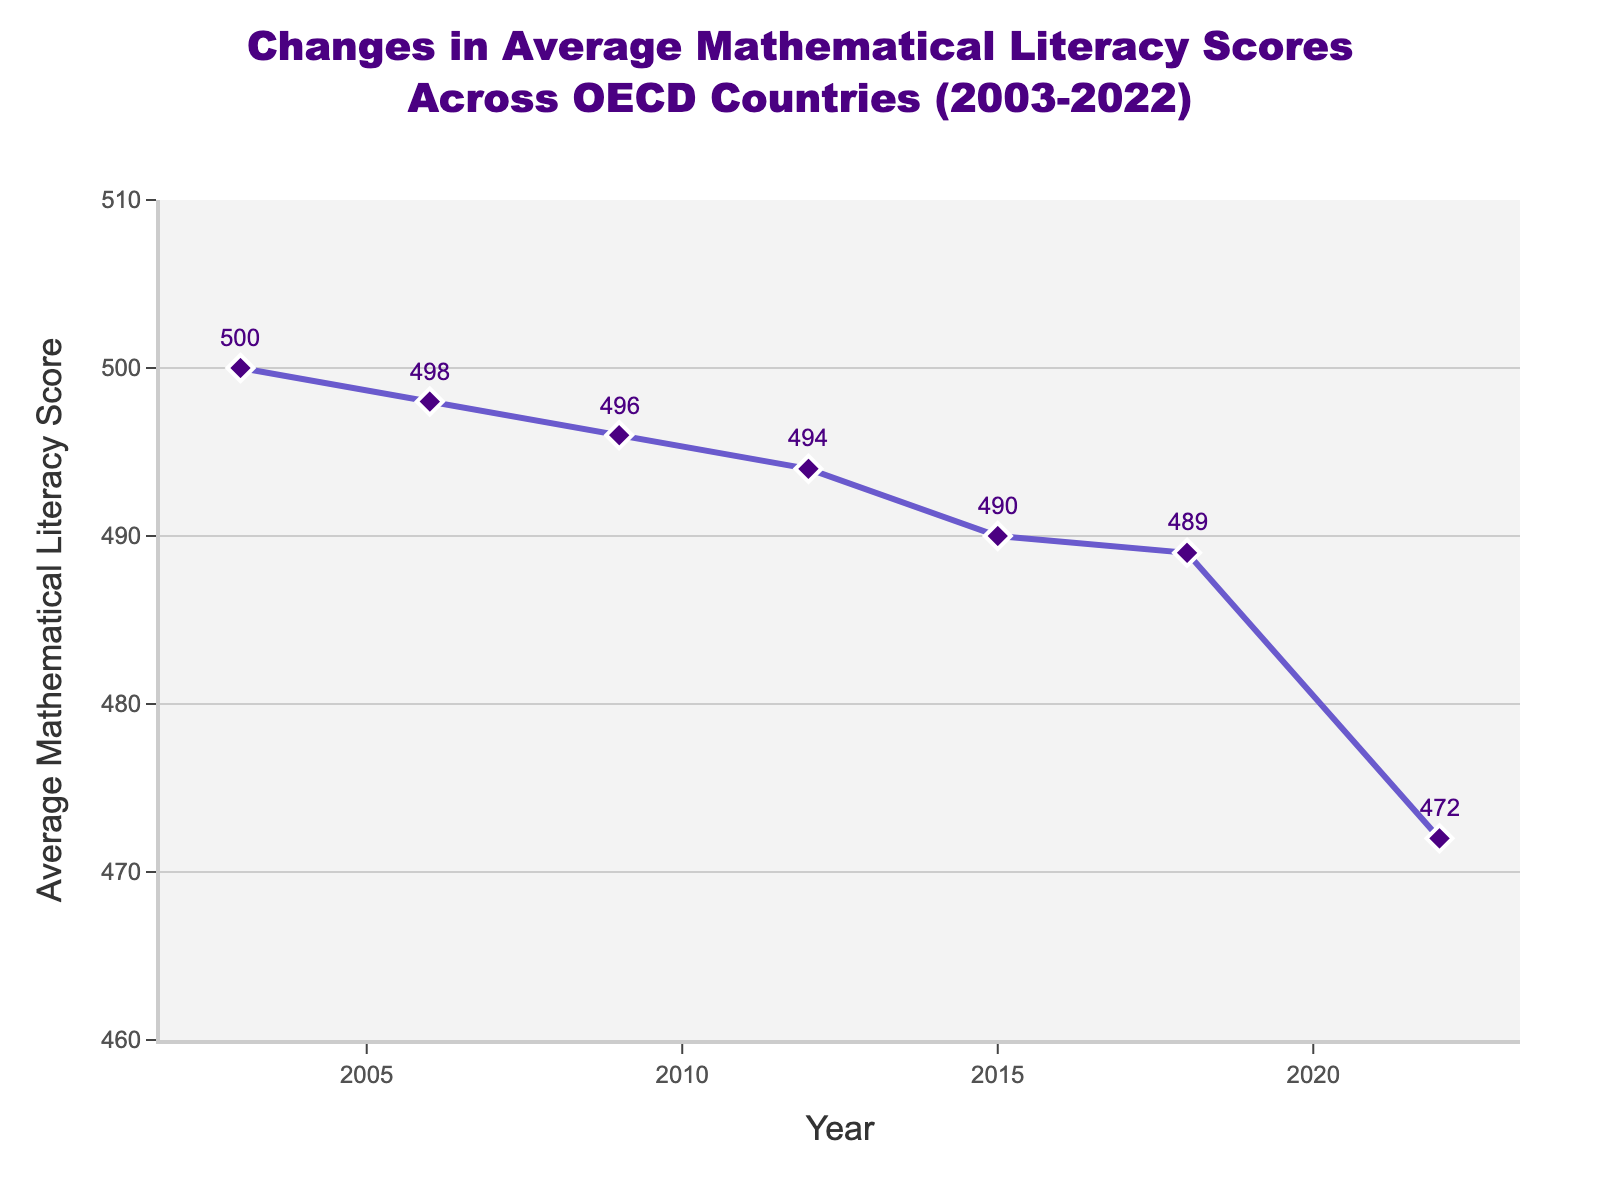What's the average mathematical literacy score from 2003 to 2022? To calculate the average score, sum all the scores and divide by the number of years. The scores are 500, 498, 496, 494, 490, 489, and 472. The sum is 3439, and there are 7 years. The average is 3439 / 7.
Answer: 491.29 In which year did the average mathematical literacy score see the biggest drop compared to the previous measurement? Looking at the differences between consecutive years: 500 to 498 (2), 498 to 496 (2), 496 to 494 (2), 494 to 490 (4), 490 to 489 (1), and 489 to 472 (17). The biggest drop is between 2018 and 2022.
Answer: 2022 How much did the average mathematical literacy score decrease from 2003 to 2022? Subtract the 2022 score from the 2003 score: 500 - 472.
Answer: 28 Which year had the highest average mathematical literacy score, and what was the value? The year with the highest score is easily identified by looking at the highest point on the line, which is 2003 with a score of 500.
Answer: 2003, 500 Is the average mathematical literacy score in 2015 higher than in 2012? Compare the two scores: 494 in 2012 and 490 in 2015. 490 is less than 494.
Answer: No By how much did the average mathematical literacy score change from 2009 to 2012? Subtract the 2012 score from the 2009 score: 496 - 494.
Answer: 2 What pattern can you observe in the average mathematical literacy scores from 2003 to 2022? The scores generally decrease over time, with slight fluctuations. The overall trend shows a downward slope.
Answer: Decreasing trend Which year had the smallest decrease in average mathematical literacy score compared to the previous measurement? Compare the differences: 500 to 498 (2), 498 to 496 (2), 496 to 494 (2), 494 to 490 (4), 490 to 489 (1), and 489 to 472 (17). The smallest decrease is between 2015 and 2018.
Answer: 2018 What is the average decline in mathematical literacy scores per year over the period from 2003 to 2022? The total decline over the period is 28 points over 6 intervals (2003-2006, 2006-2009, etc.). The average decline per interval is 28 / 6.
Answer: 4.67 